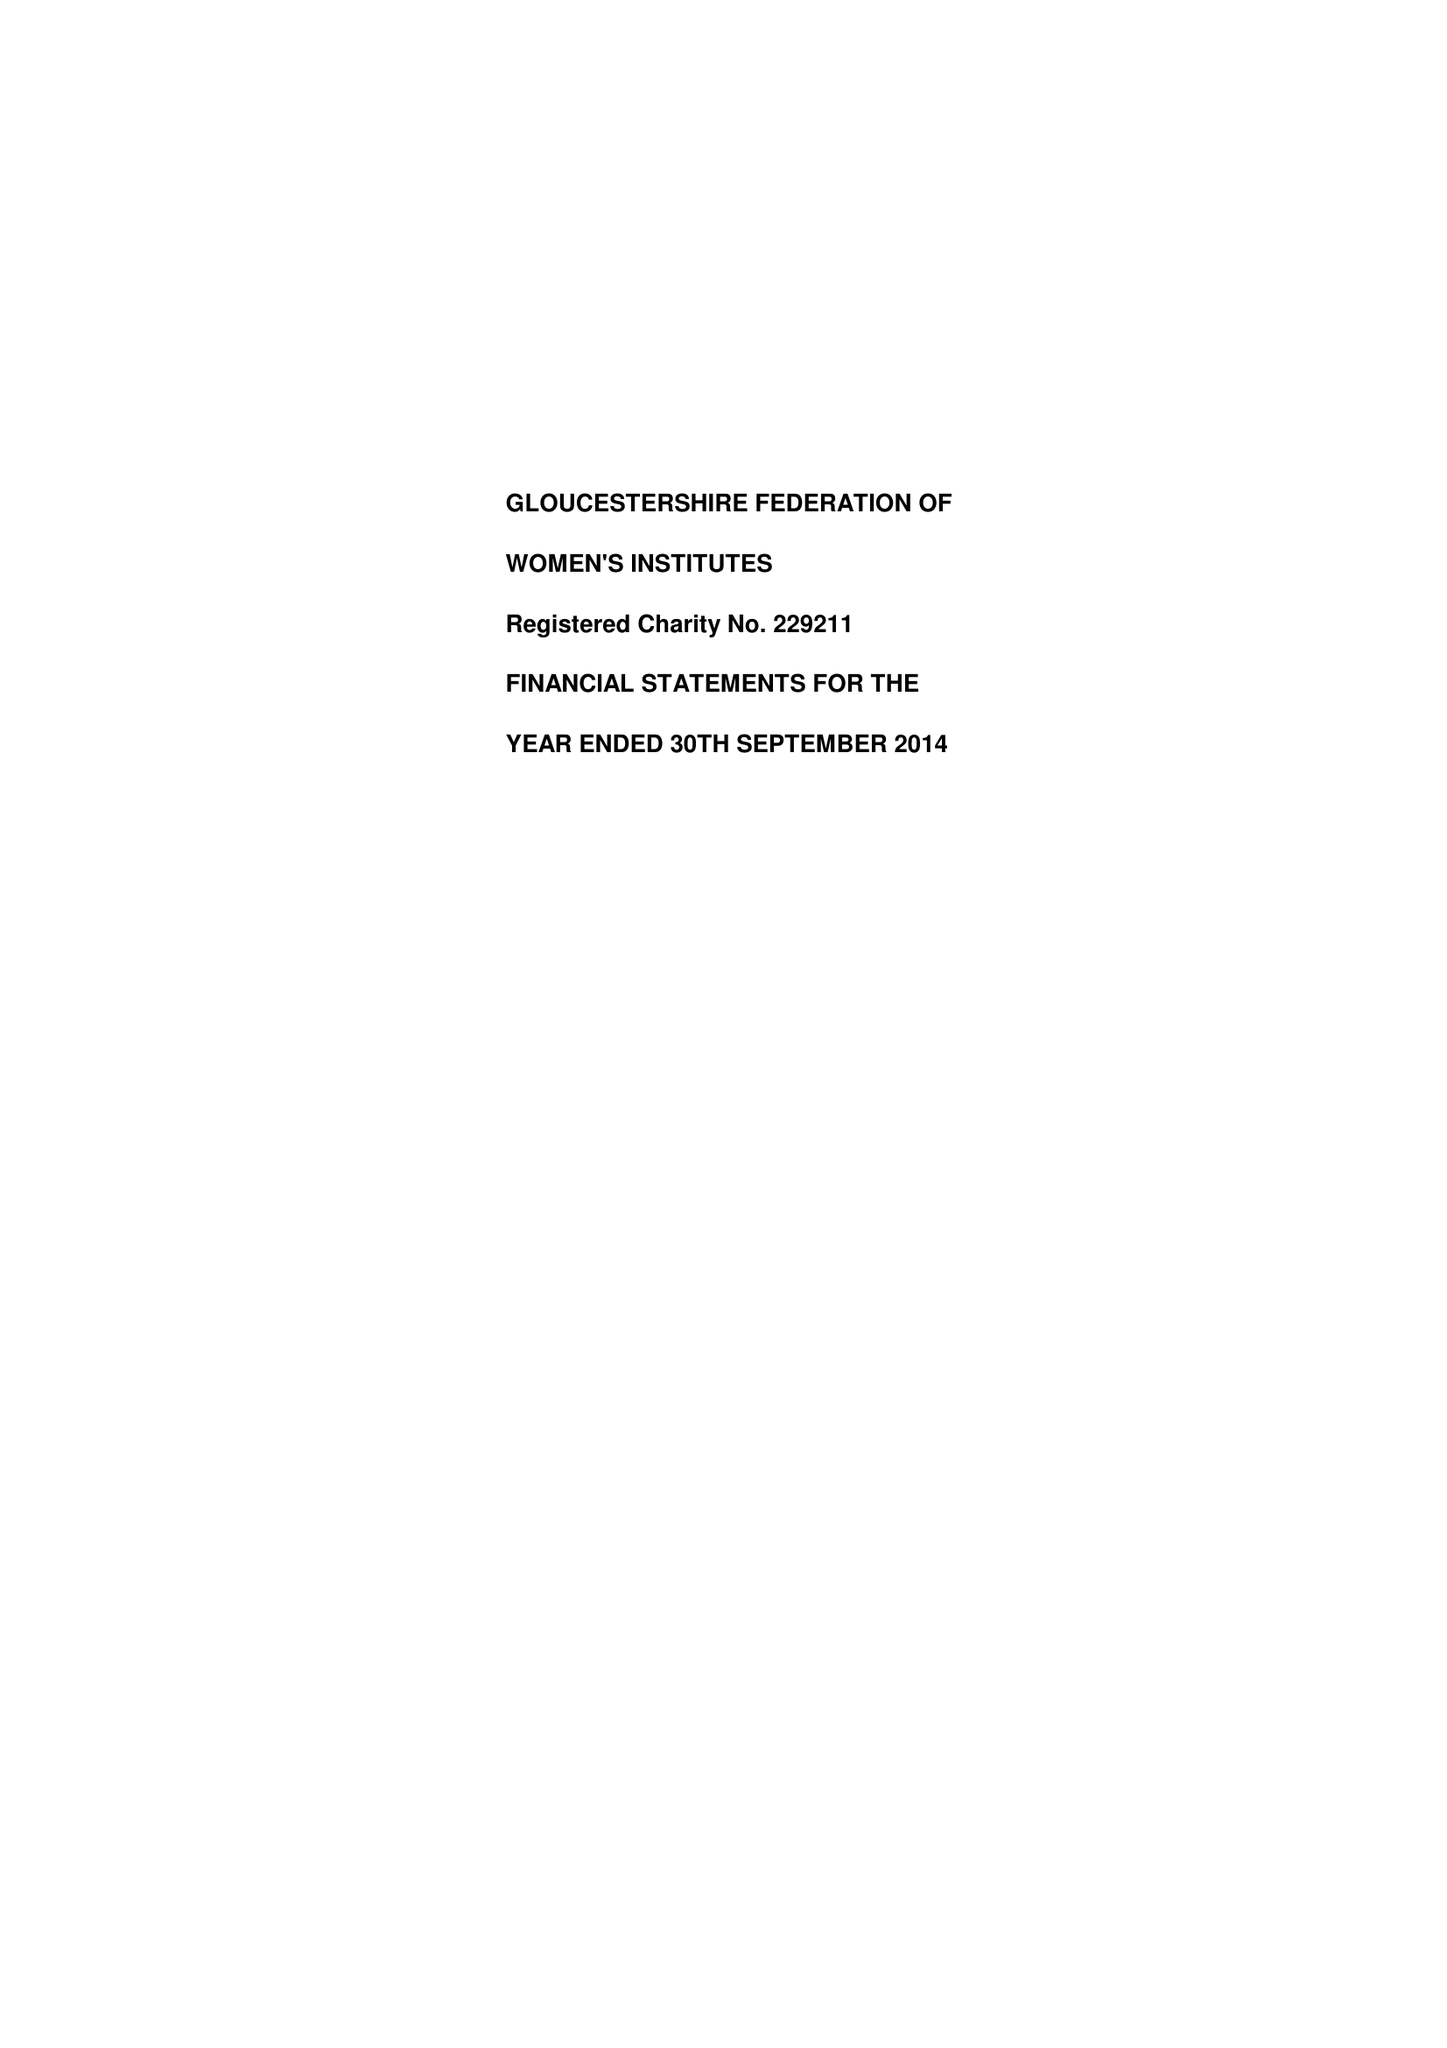What is the value for the address__street_line?
Answer the question using a single word or phrase. 2 BRUNSWICK SQUARE 